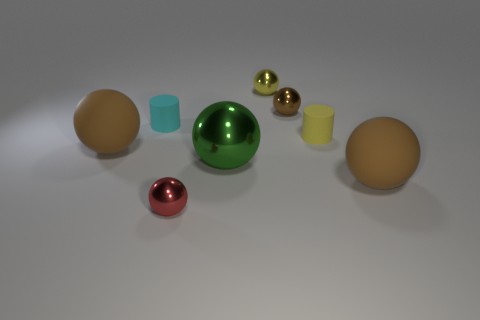How many brown spheres must be subtracted to get 2 brown spheres? 1 Subtract all yellow balls. How many balls are left? 5 Subtract all green shiny spheres. How many spheres are left? 5 Subtract 0 green cylinders. How many objects are left? 8 Subtract all spheres. How many objects are left? 2 Subtract 1 cylinders. How many cylinders are left? 1 Subtract all blue cylinders. Subtract all gray blocks. How many cylinders are left? 2 Subtract all purple spheres. How many purple cylinders are left? 0 Subtract all large red shiny balls. Subtract all tiny brown shiny objects. How many objects are left? 7 Add 3 large brown spheres. How many large brown spheres are left? 5 